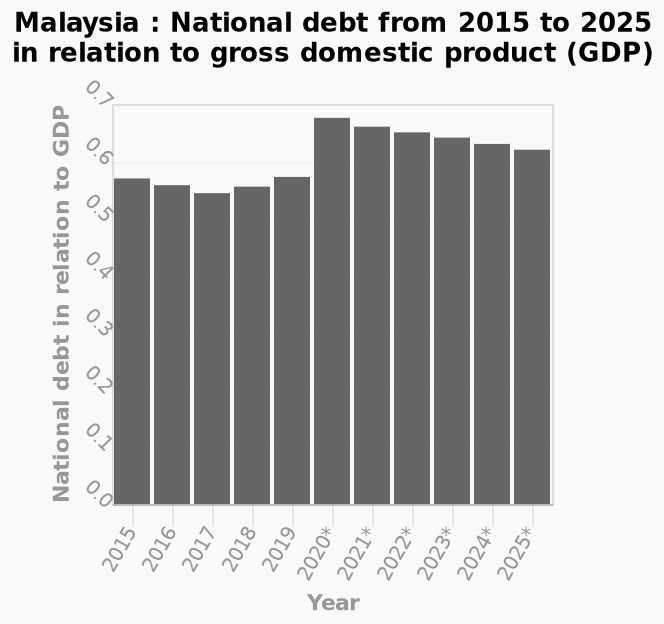<image>
What is the minimum value on the y-axis scale? The minimum value on the y-axis scale is 0.0. What was the national debt in relation to GDP in Malaysia in 2020?  In 2020, the national debt in relation to GDP in Malaysia spiked to just under 0.70. What is the maximum value on the y-axis scale? The maximum value on the y-axis scale is 0.7. What was the trend in Malaysia's national debt in relation to GDP from 2015 to 2025? From 2015 to 2020, Malaysia's national debt in relation to GDP stayed around 0.55. However, in 2020, it spiked to just under 0.70 and has been steadily decreasing from 2021 to 2025. 